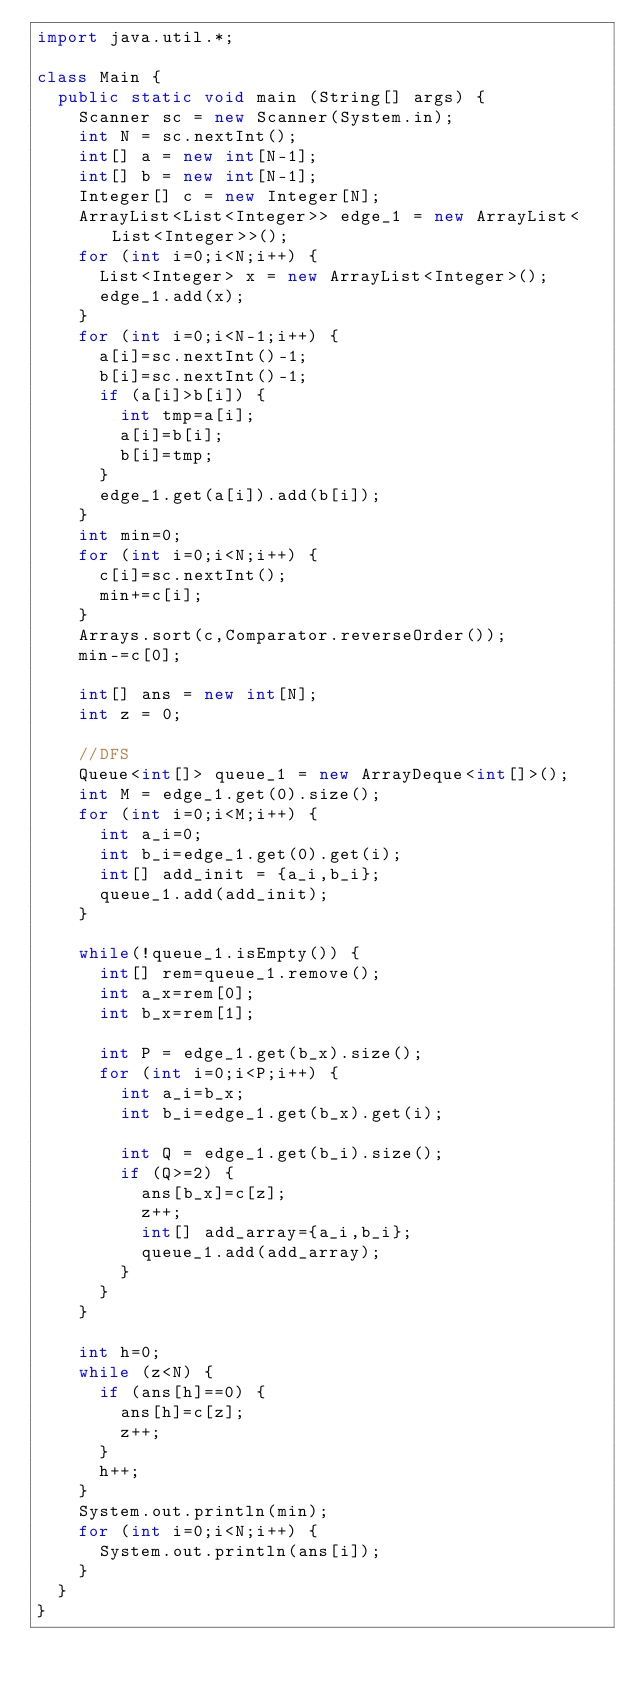Convert code to text. <code><loc_0><loc_0><loc_500><loc_500><_Java_>import java.util.*;

class Main {
	public static void main (String[] args) {
		Scanner sc = new Scanner(System.in);
		int N = sc.nextInt();
		int[] a = new int[N-1];
		int[] b = new int[N-1];
		Integer[] c = new Integer[N];
		ArrayList<List<Integer>> edge_1 = new ArrayList<List<Integer>>();
		for (int i=0;i<N;i++) {
			List<Integer> x = new ArrayList<Integer>();
			edge_1.add(x);
		}
		for (int i=0;i<N-1;i++) {
			a[i]=sc.nextInt()-1;
			b[i]=sc.nextInt()-1;
			if (a[i]>b[i]) {
				int tmp=a[i];
				a[i]=b[i];
				b[i]=tmp;
			}
			edge_1.get(a[i]).add(b[i]);
		}
		int min=0;
		for (int i=0;i<N;i++) {
			c[i]=sc.nextInt();
			min+=c[i];
		}
		Arrays.sort(c,Comparator.reverseOrder());
		min-=c[0];

		int[] ans = new int[N];
		int z = 0;

		//DFS
		Queue<int[]> queue_1 = new ArrayDeque<int[]>();
		int M = edge_1.get(0).size();
		for (int i=0;i<M;i++) {
			int a_i=0;
			int b_i=edge_1.get(0).get(i);
			int[] add_init = {a_i,b_i};
			queue_1.add(add_init);
		}

		while(!queue_1.isEmpty()) {
			int[] rem=queue_1.remove();
			int a_x=rem[0];
			int b_x=rem[1];

			int P = edge_1.get(b_x).size();
			for (int i=0;i<P;i++) {
				int a_i=b_x;
				int b_i=edge_1.get(b_x).get(i);

				int Q = edge_1.get(b_i).size();
				if (Q>=2) {
					ans[b_x]=c[z];
					z++;
					int[] add_array={a_i,b_i};
					queue_1.add(add_array);
				}
			}
		}

		int h=0;
		while (z<N) {
			if (ans[h]==0) {
				ans[h]=c[z];
				z++;
			}
			h++;
		}
		System.out.println(min);
		for (int i=0;i<N;i++) {
			System.out.println(ans[i]);
		}
	}
}</code> 